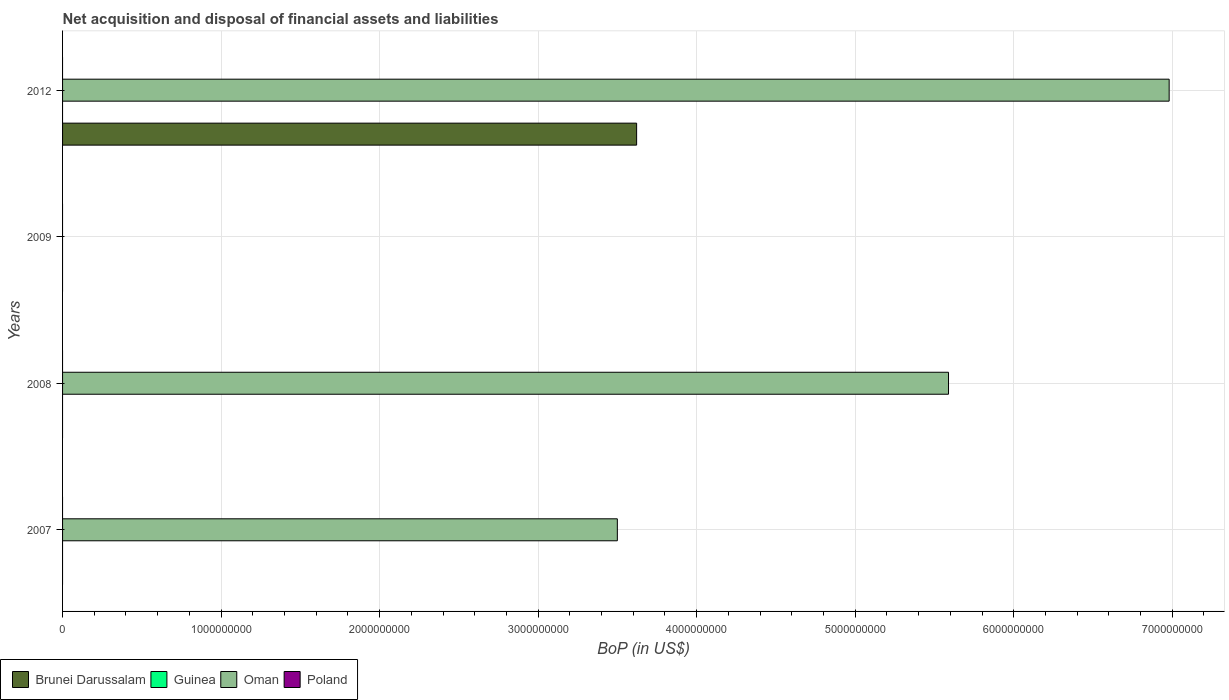How many different coloured bars are there?
Provide a short and direct response. 2. Are the number of bars on each tick of the Y-axis equal?
Your response must be concise. No. How many bars are there on the 2nd tick from the top?
Provide a succinct answer. 0. How many bars are there on the 1st tick from the bottom?
Keep it short and to the point. 1. What is the label of the 3rd group of bars from the top?
Offer a terse response. 2008. Across all years, what is the maximum Balance of Payments in Oman?
Make the answer very short. 6.98e+09. In which year was the Balance of Payments in Oman maximum?
Your answer should be very brief. 2012. What is the difference between the Balance of Payments in Oman in 2007 and that in 2008?
Your answer should be compact. -2.09e+09. What is the difference between the Balance of Payments in Brunei Darussalam in 2009 and the Balance of Payments in Oman in 2007?
Give a very brief answer. -3.50e+09. What is the average Balance of Payments in Brunei Darussalam per year?
Your answer should be compact. 9.05e+08. What is the ratio of the Balance of Payments in Oman in 2007 to that in 2008?
Your answer should be compact. 0.63. What is the difference between the highest and the second highest Balance of Payments in Oman?
Offer a terse response. 1.39e+09. What is the difference between the highest and the lowest Balance of Payments in Oman?
Give a very brief answer. 6.98e+09. In how many years, is the Balance of Payments in Poland greater than the average Balance of Payments in Poland taken over all years?
Offer a terse response. 0. Are all the bars in the graph horizontal?
Ensure brevity in your answer.  Yes. What is the difference between two consecutive major ticks on the X-axis?
Provide a succinct answer. 1.00e+09. Are the values on the major ticks of X-axis written in scientific E-notation?
Offer a very short reply. No. What is the title of the graph?
Provide a short and direct response. Net acquisition and disposal of financial assets and liabilities. What is the label or title of the X-axis?
Your answer should be compact. BoP (in US$). What is the BoP (in US$) in Brunei Darussalam in 2007?
Keep it short and to the point. 0. What is the BoP (in US$) in Oman in 2007?
Give a very brief answer. 3.50e+09. What is the BoP (in US$) of Poland in 2007?
Offer a very short reply. 0. What is the BoP (in US$) of Brunei Darussalam in 2008?
Ensure brevity in your answer.  0. What is the BoP (in US$) in Guinea in 2008?
Keep it short and to the point. 0. What is the BoP (in US$) in Oman in 2008?
Ensure brevity in your answer.  5.59e+09. What is the BoP (in US$) of Poland in 2009?
Your answer should be compact. 0. What is the BoP (in US$) of Brunei Darussalam in 2012?
Keep it short and to the point. 3.62e+09. What is the BoP (in US$) in Guinea in 2012?
Ensure brevity in your answer.  0. What is the BoP (in US$) of Oman in 2012?
Your response must be concise. 6.98e+09. What is the BoP (in US$) in Poland in 2012?
Your response must be concise. 0. Across all years, what is the maximum BoP (in US$) of Brunei Darussalam?
Provide a succinct answer. 3.62e+09. Across all years, what is the maximum BoP (in US$) of Oman?
Offer a terse response. 6.98e+09. Across all years, what is the minimum BoP (in US$) of Oman?
Provide a succinct answer. 0. What is the total BoP (in US$) of Brunei Darussalam in the graph?
Your answer should be very brief. 3.62e+09. What is the total BoP (in US$) of Guinea in the graph?
Keep it short and to the point. 0. What is the total BoP (in US$) of Oman in the graph?
Your answer should be compact. 1.61e+1. What is the difference between the BoP (in US$) in Oman in 2007 and that in 2008?
Your response must be concise. -2.09e+09. What is the difference between the BoP (in US$) in Oman in 2007 and that in 2012?
Provide a short and direct response. -3.48e+09. What is the difference between the BoP (in US$) of Oman in 2008 and that in 2012?
Provide a succinct answer. -1.39e+09. What is the average BoP (in US$) in Brunei Darussalam per year?
Ensure brevity in your answer.  9.05e+08. What is the average BoP (in US$) in Guinea per year?
Offer a very short reply. 0. What is the average BoP (in US$) of Oman per year?
Keep it short and to the point. 4.02e+09. In the year 2012, what is the difference between the BoP (in US$) of Brunei Darussalam and BoP (in US$) of Oman?
Offer a terse response. -3.36e+09. What is the ratio of the BoP (in US$) of Oman in 2007 to that in 2008?
Your response must be concise. 0.63. What is the ratio of the BoP (in US$) in Oman in 2007 to that in 2012?
Provide a succinct answer. 0.5. What is the ratio of the BoP (in US$) of Oman in 2008 to that in 2012?
Provide a short and direct response. 0.8. What is the difference between the highest and the second highest BoP (in US$) of Oman?
Offer a terse response. 1.39e+09. What is the difference between the highest and the lowest BoP (in US$) in Brunei Darussalam?
Your answer should be compact. 3.62e+09. What is the difference between the highest and the lowest BoP (in US$) of Oman?
Provide a short and direct response. 6.98e+09. 